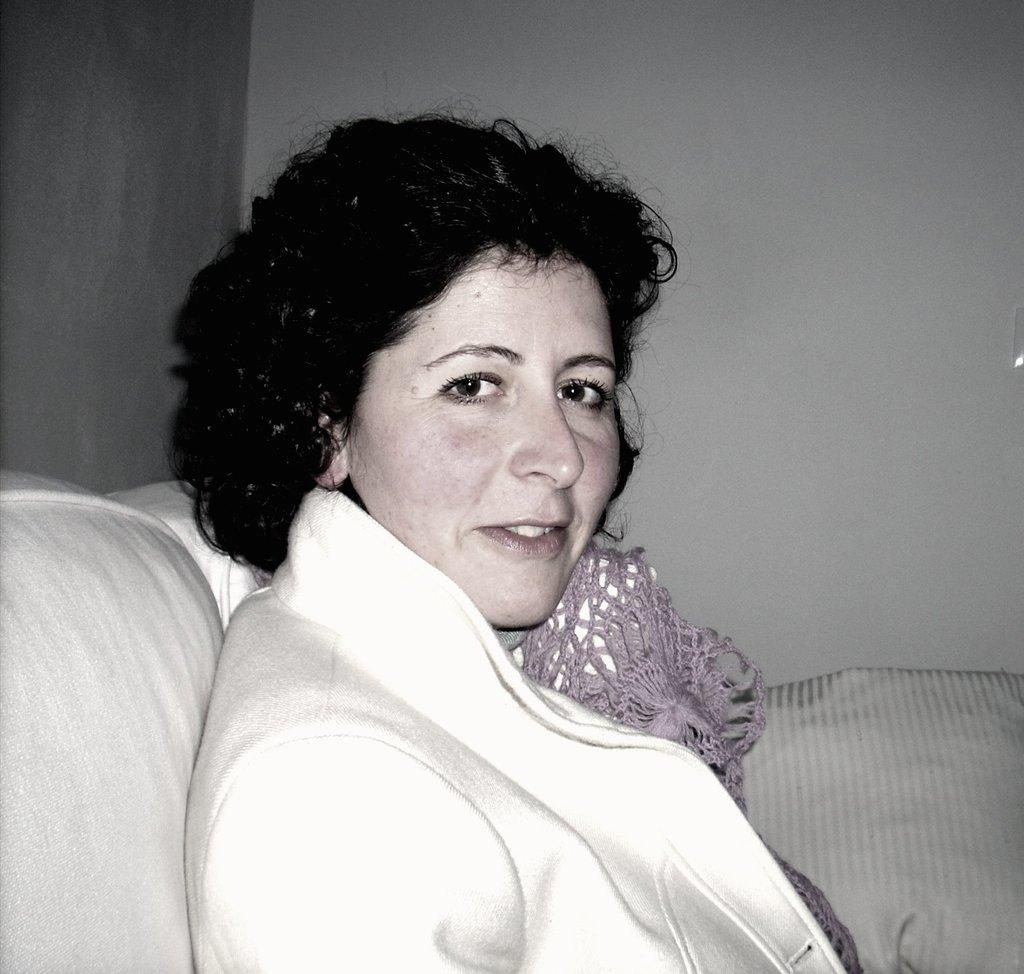Who is the main subject in the image? There is a woman in the image. What is the woman wearing? The woman is wearing a white jacket. What is the woman doing in the image? The woman is sitting on a sofa. What can be seen behind the woman? There is a wall visible in the image. Is the woman wearing a veil in the image? No, the woman is not wearing a veil in the image; she is wearing a white jacket. 